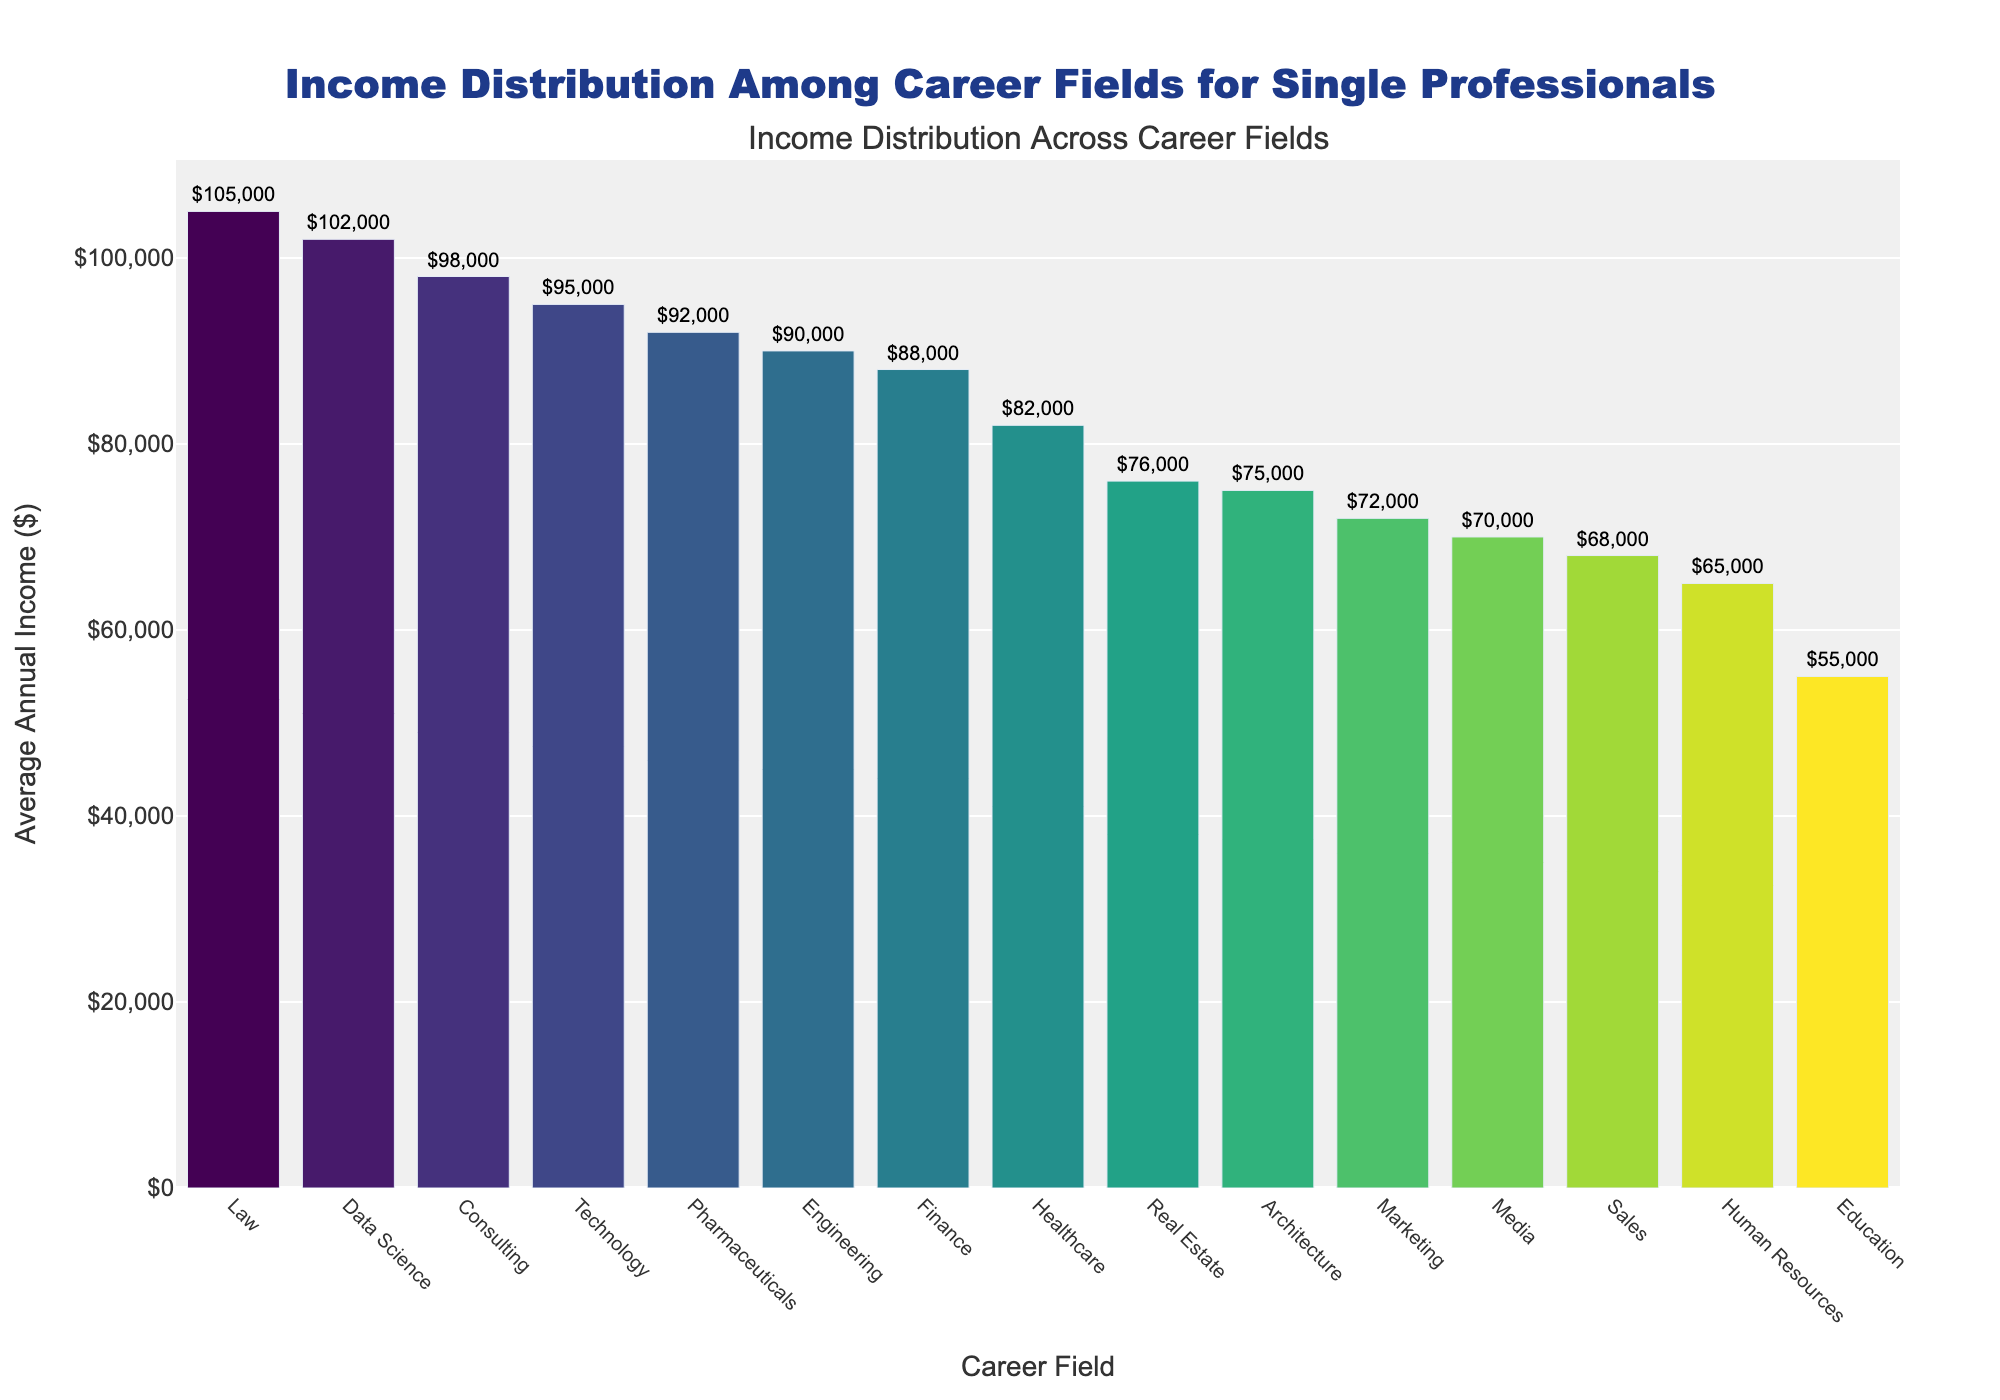What's the highest average annual income among the career fields? Identify the tallest bar in the chart, which represents the highest average income. The "Law" field has the tallest bar indicating an average income of $105,000.
Answer: $105,000 Which career field has the lowest average annual income? Locate the shortest bar in the chart. The bar representing "Education" is the shortest, indicating the lowest average income of $55,000.
Answer: Education What is the difference in average annual income between the Technology and Sales fields? Identify the bars for "Technology" and "Sales." Technology has an average income of $95,000, and Sales has $68,000. Calculate the difference: $95,000 - $68,000 = $27,000.
Answer: $27,000 How much higher is the average annual income in Data Science compared to Real Estate? Find the bars for "Data Science" and "Real Estate." Data Science has an average income of $102,000, and Real Estate has $76,000. Calculate the difference: $102,000 - $76,000 = $26,000.
Answer: $26,000 Which career field has a higher average annual income: Finance or Healthcare? Compare the bars representing "Finance" and "Healthcare." Finance has an average income of $88,000, and Healthcare has $82,000. Finance is higher.
Answer: Finance What is the average annual income for the Media field? Locate the bar labeled "Media" in the chart. The text outside the bar indicates the average income for Media is $70,000.
Answer: $70,000 How does the average annual income of Consulting compare to Pharmaceuticals? Compare the heights of the bars for "Consulting" and "Pharmaceuticals." Consulting has an average income of $98,000, and Pharmaceuticals have $92,000. Consulting is higher.
Answer: Consulting What is the combined average annual income of the top three highest-paying career fields? Identify the top three bars: "Law" ($105,000), "Data Science" ($102,000), and "Consulting" ($98,000). Sum these values: $105,000 + $102,000 + $98,000 = $305,000.
Answer: $305,000 How many career fields have an average annual income of $90,000 or more? Count the number of bars that reach or exceed the $90,000 mark: Technology ($95,000), Finance ($88,000), Law ($105,000), Engineering ($90,000), Consulting ($98,000), Pharmaceuticals ($92,000), and Data Science ($102,000). There are seven fields.
Answer: 7 Which career field has an average annual income closest to $75,000? Identify the bar closest to the $75,000 mark. "Architecture" has an average income of $75,000, making it the closest to this value.
Answer: Architecture 